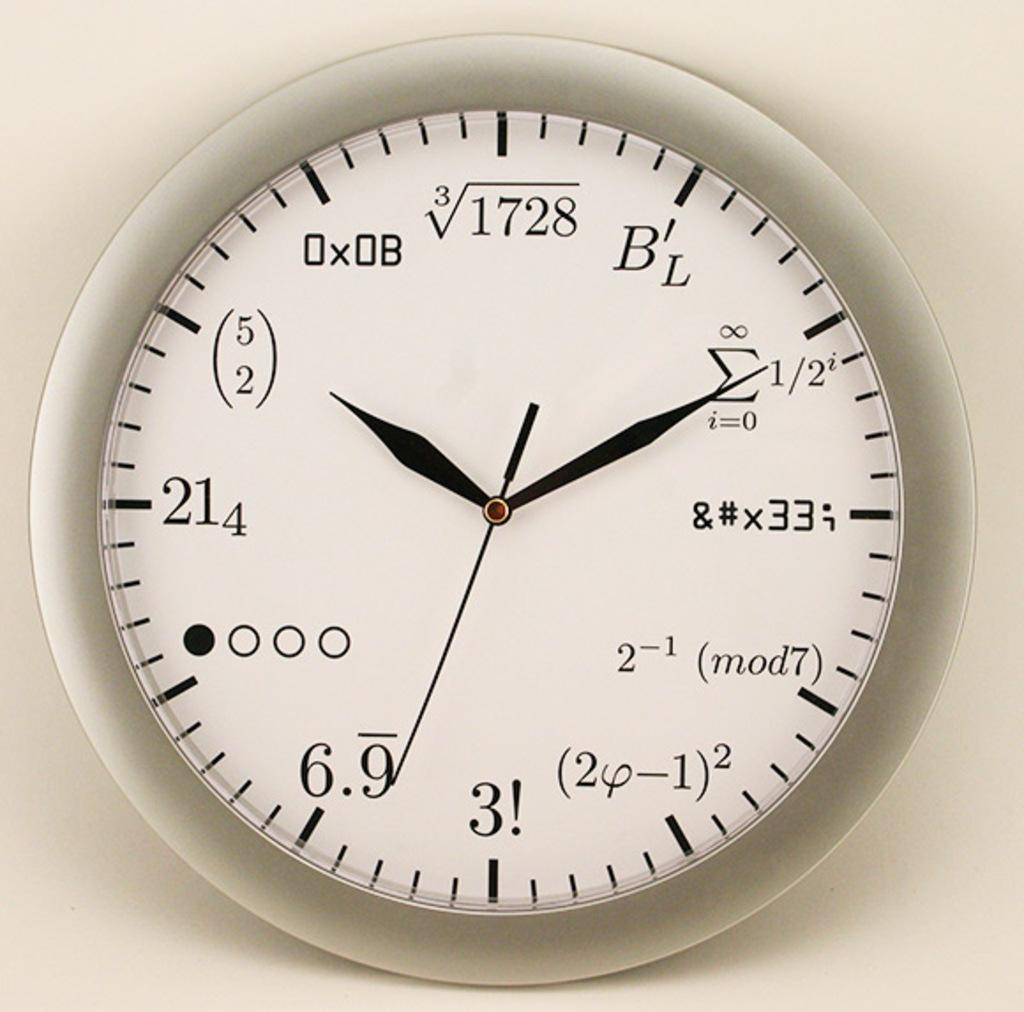<image>
Summarize the visual content of the image. A clock with mathematical equation like 2-1 where the numbers should be. 